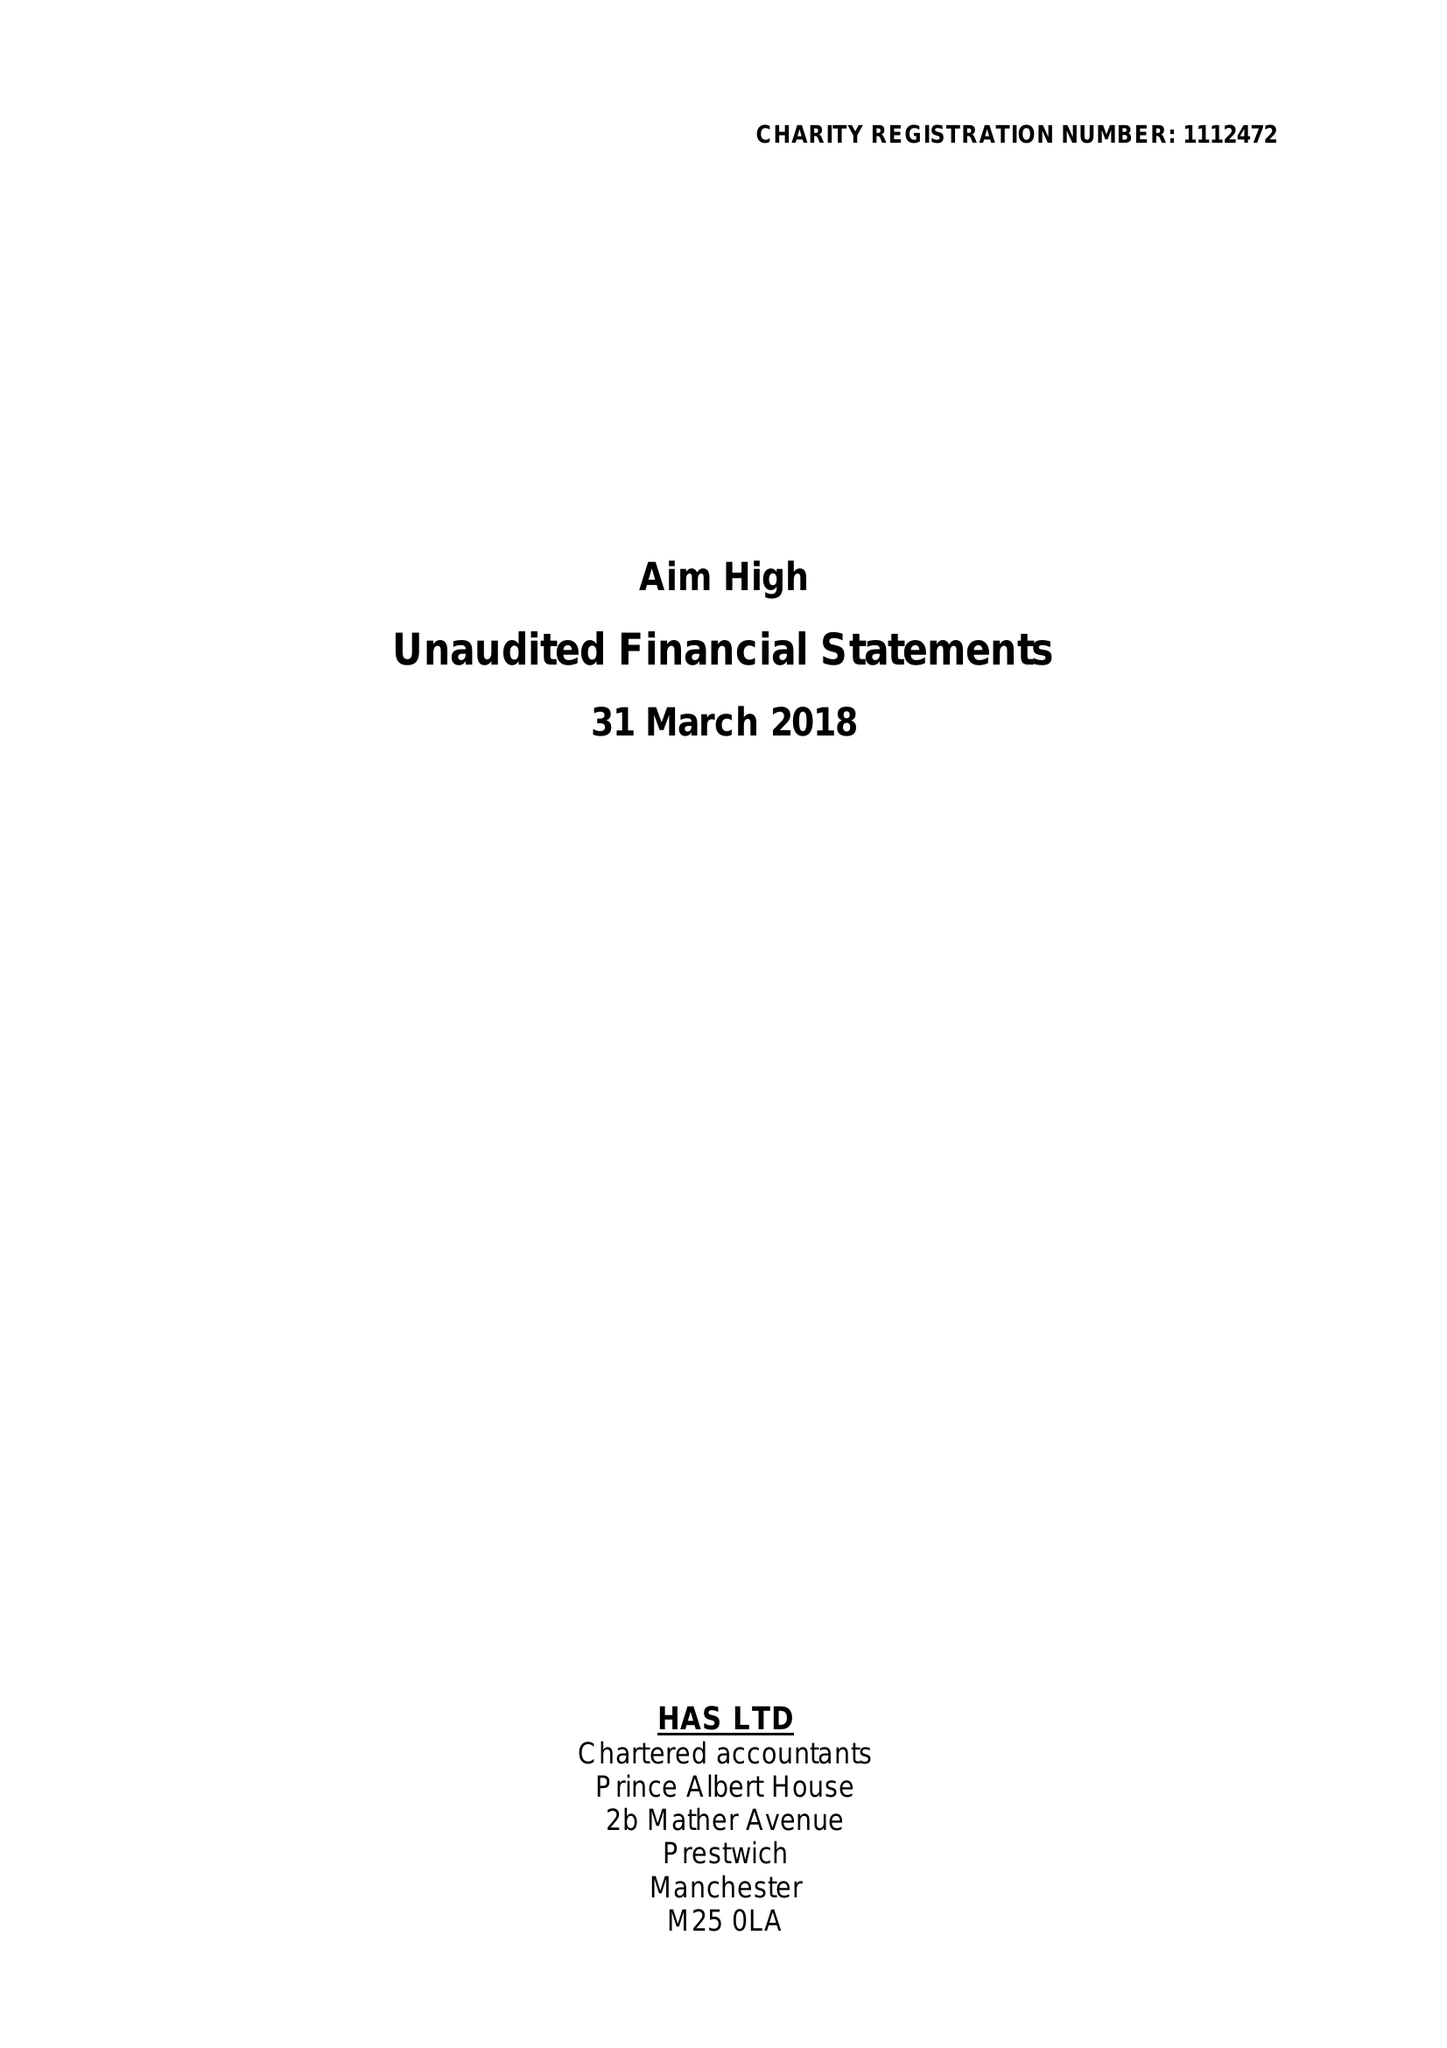What is the value for the income_annually_in_british_pounds?
Answer the question using a single word or phrase. 63173.00 